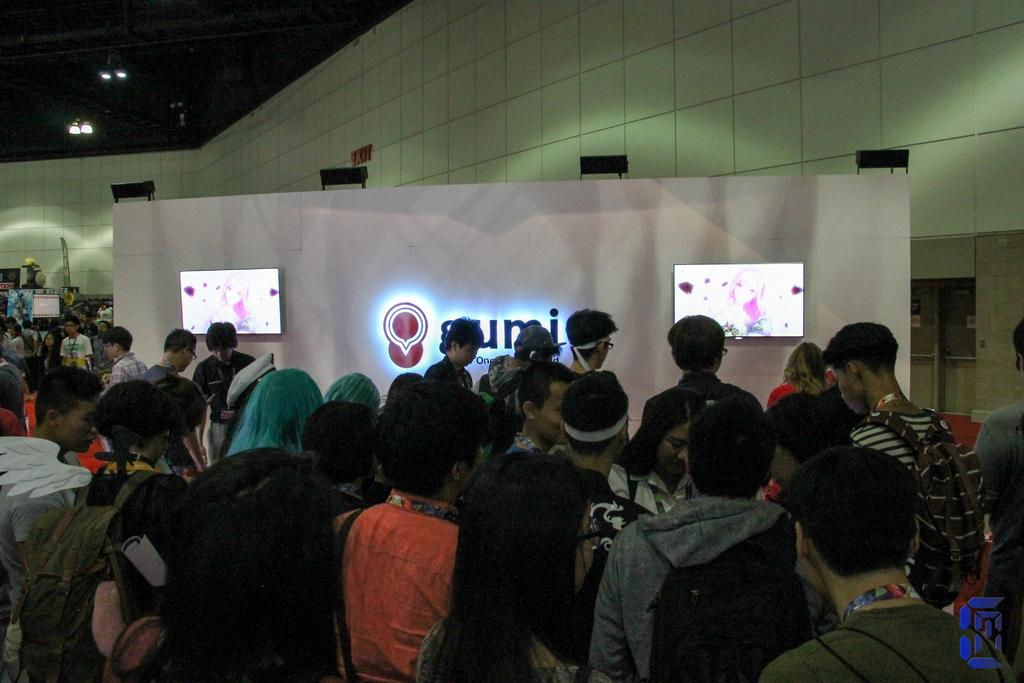What is happening in the room in the image? There are people standing in the room. What is in the middle of the room? There is a board in the middle of the room. What is on the board? There are two LED TV screens on the board. What can be seen in the background of the image? There is a wall visible in the background. Can you hear the robin singing in the image? There is no robin present in the image, so it is not possible to hear it singing. Is there a volleyball game happening in the room? There is no indication of a volleyball game in the image; it shows people standing around a board with LED TV screens. 